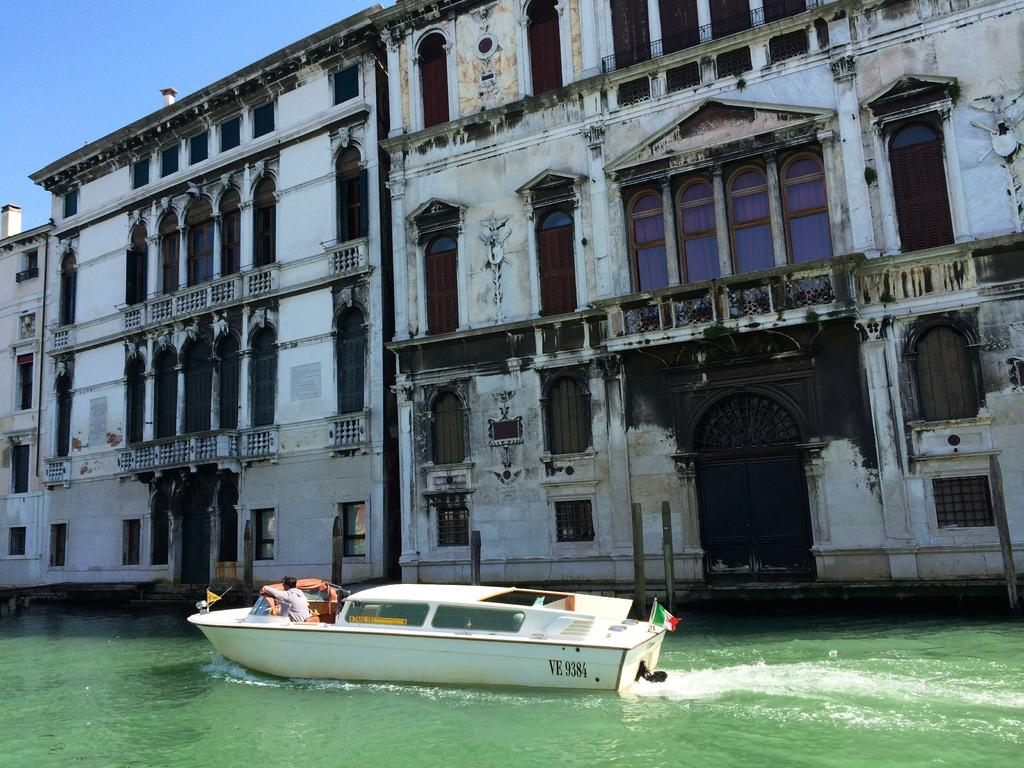<image>
Write a terse but informative summary of the picture. VE 9384 white boat in the water with a Italy flag on back. 